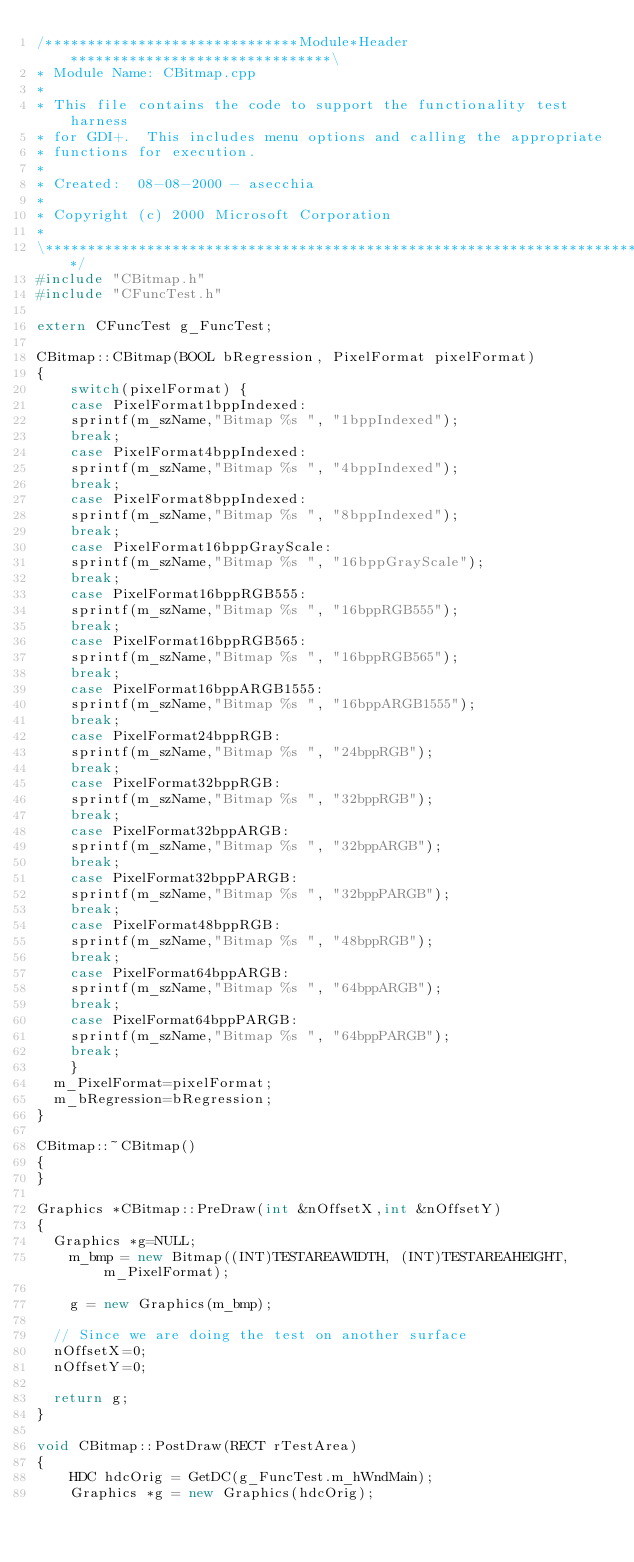<code> <loc_0><loc_0><loc_500><loc_500><_C++_>/******************************Module*Header*******************************\
* Module Name: CBitmap.cpp
*
* This file contains the code to support the functionality test harness
* for GDI+.  This includes menu options and calling the appropriate
* functions for execution.
*
* Created:  08-08-2000 - asecchia
*
* Copyright (c) 2000 Microsoft Corporation
*
\**************************************************************************/
#include "CBitmap.h"
#include "CFuncTest.h"

extern CFuncTest g_FuncTest;

CBitmap::CBitmap(BOOL bRegression, PixelFormat pixelFormat)
{
    switch(pixelFormat) {
    case PixelFormat1bppIndexed:
    sprintf(m_szName,"Bitmap %s ", "1bppIndexed");
    break;
    case PixelFormat4bppIndexed:    	
    sprintf(m_szName,"Bitmap %s ", "4bppIndexed");
    break;
    case PixelFormat8bppIndexed:        
    sprintf(m_szName,"Bitmap %s ", "8bppIndexed");
    break;
    case PixelFormat16bppGrayScale:     
    sprintf(m_szName,"Bitmap %s ", "16bppGrayScale");
    break;
    case PixelFormat16bppRGB555:        
    sprintf(m_szName,"Bitmap %s ", "16bppRGB555");
    break;
    case PixelFormat16bppRGB565:        
    sprintf(m_szName,"Bitmap %s ", "16bppRGB565");
    break;
    case PixelFormat16bppARGB1555:      
    sprintf(m_szName,"Bitmap %s ", "16bppARGB1555");
    break;
    case PixelFormat24bppRGB:           
    sprintf(m_szName,"Bitmap %s ", "24bppRGB");
    break;
    case PixelFormat32bppRGB:           
    sprintf(m_szName,"Bitmap %s ", "32bppRGB");
    break;
    case PixelFormat32bppARGB:          
    sprintf(m_szName,"Bitmap %s ", "32bppARGB");
    break;
    case PixelFormat32bppPARGB:         
    sprintf(m_szName,"Bitmap %s ", "32bppPARGB");
    break;
    case PixelFormat48bppRGB:           
    sprintf(m_szName,"Bitmap %s ", "48bppRGB");
    break;
    case PixelFormat64bppARGB:          
    sprintf(m_szName,"Bitmap %s ", "64bppARGB");
    break;
    case PixelFormat64bppPARGB:         
    sprintf(m_szName,"Bitmap %s ", "64bppPARGB");
    break;
    }
	m_PixelFormat=pixelFormat;
	m_bRegression=bRegression;
}

CBitmap::~CBitmap()
{
}

Graphics *CBitmap::PreDraw(int &nOffsetX,int &nOffsetY)
{
	Graphics *g=NULL;
    m_bmp = new Bitmap((INT)TESTAREAWIDTH, (INT)TESTAREAHEIGHT, m_PixelFormat);

    g = new Graphics(m_bmp);

	// Since we are doing the test on another surface
	nOffsetX=0;
	nOffsetY=0;

	return g;
}

void CBitmap::PostDraw(RECT rTestArea)
{
    HDC hdcOrig = GetDC(g_FuncTest.m_hWndMain);
    Graphics *g = new Graphics(hdcOrig);</code> 